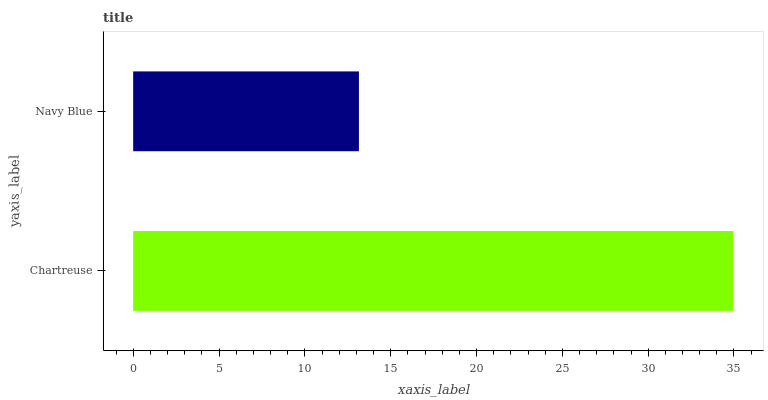Is Navy Blue the minimum?
Answer yes or no. Yes. Is Chartreuse the maximum?
Answer yes or no. Yes. Is Navy Blue the maximum?
Answer yes or no. No. Is Chartreuse greater than Navy Blue?
Answer yes or no. Yes. Is Navy Blue less than Chartreuse?
Answer yes or no. Yes. Is Navy Blue greater than Chartreuse?
Answer yes or no. No. Is Chartreuse less than Navy Blue?
Answer yes or no. No. Is Chartreuse the high median?
Answer yes or no. Yes. Is Navy Blue the low median?
Answer yes or no. Yes. Is Navy Blue the high median?
Answer yes or no. No. Is Chartreuse the low median?
Answer yes or no. No. 